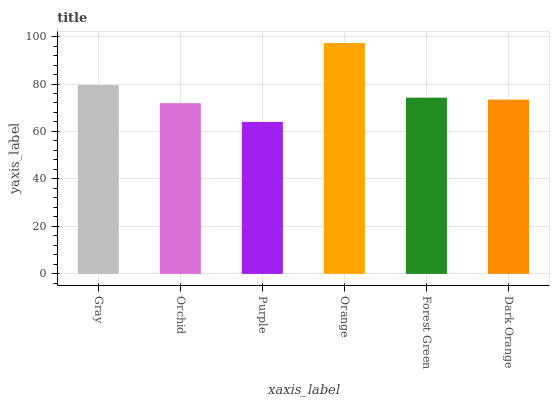Is Purple the minimum?
Answer yes or no. Yes. Is Orange the maximum?
Answer yes or no. Yes. Is Orchid the minimum?
Answer yes or no. No. Is Orchid the maximum?
Answer yes or no. No. Is Gray greater than Orchid?
Answer yes or no. Yes. Is Orchid less than Gray?
Answer yes or no. Yes. Is Orchid greater than Gray?
Answer yes or no. No. Is Gray less than Orchid?
Answer yes or no. No. Is Forest Green the high median?
Answer yes or no. Yes. Is Dark Orange the low median?
Answer yes or no. Yes. Is Purple the high median?
Answer yes or no. No. Is Orange the low median?
Answer yes or no. No. 